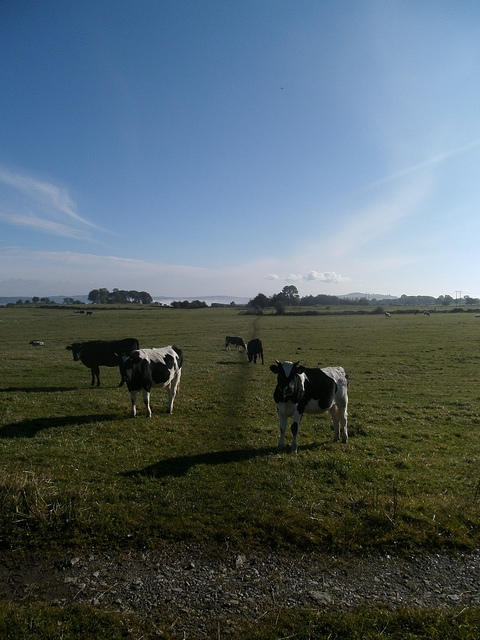<image>What type of fabric is made from the coats of these animals? I am not sure what type of fabric is made from the coats of these animals. It can be either wool, leather, or cotton. What type of fabric is made from the coats of these animals? It is unanswerable what type of fabric is made from the coats of these animals. 